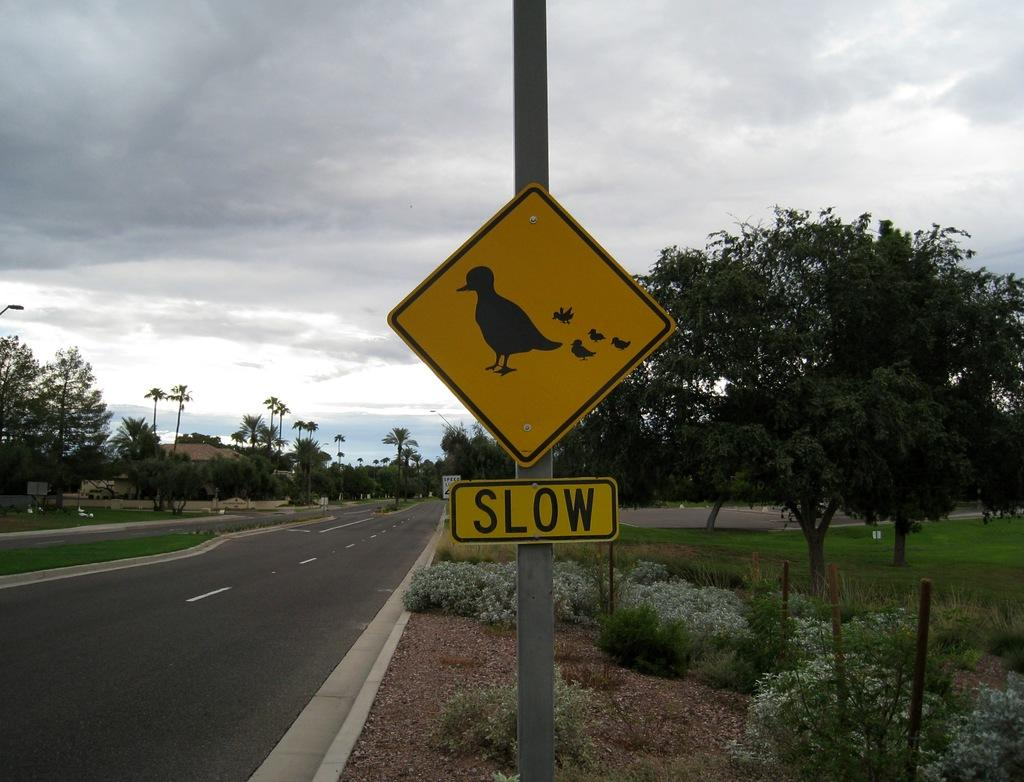Provide a one-sentence caption for the provided image. A Slow sign is beneath a sign with a pciture of a bird and chicks. 